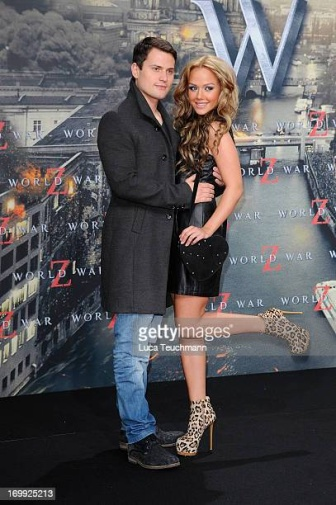What can you infer about the relationship between the man and woman in this image? The man and woman appear to share a close and affectionate relationship. They are standing very close to each other, with the man's arm around the woman's waist, and the woman is leaning in slightly, suggesting intimacy and comfort. This body language indicates that they could be a couple or very close friends. Do you think they attended this event together? Yes, it seems likely that they attended the event together. Their coordinated pose and close proximity to each other in front of the promotional poster suggest they came to the event as a pair, possibly enjoying the occasion together. Imagine they are characters in a movie. Describe a scene featuring these two. In a bustling cityscape reminiscent of 'World War Z,' the man and woman find themselves amidst chaos as the city is overrun by a mysterious, fast-spreading infection. Despite the turmoil, they stick together, navigating through dark alleyways and deserted streets. The man, with determination in his eyes, leads the way, his arm protectively around the woman. She, in her stylish black dress and leopard print heels, is both fierce and poised, her strength and elegance shining through even in such dire circumstances. They fight their way through hordes of infected, their bond strengthening with each passing moment of danger, ultimately finding a safe haven where they can regroup and plan their next move. 